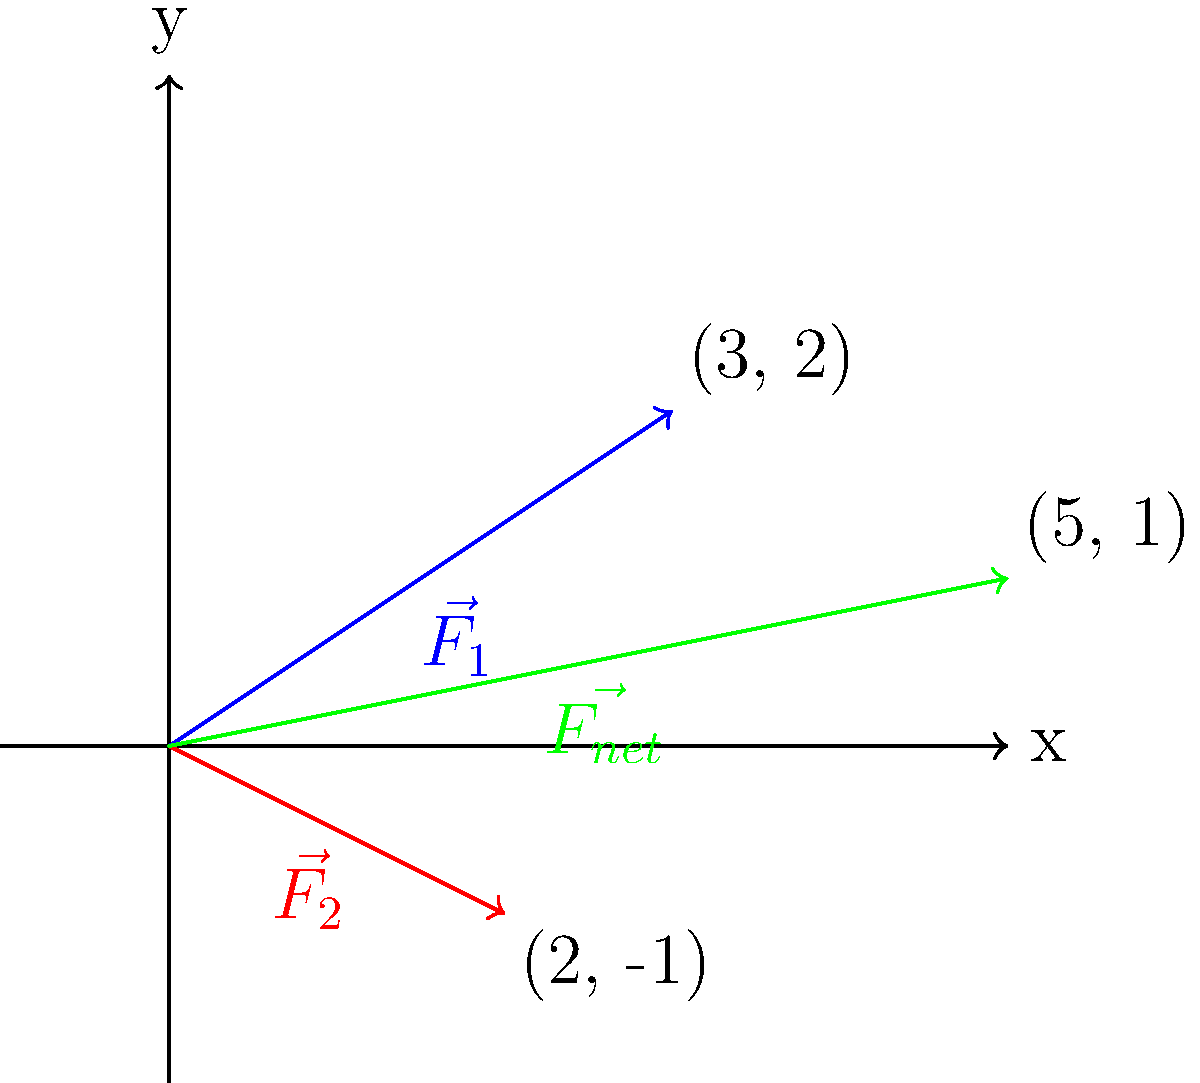In a championship match, you're about to execute your signature takedown technique. The technique involves applying two forces simultaneously: $\vec{F_1} = 3\hat{i} + 2\hat{j}$ and $\vec{F_2} = 2\hat{i} - \hat{j}$ (in arbitrary units). What is the magnitude of the net force $\vec{F_{net}}$ applied during this takedown? To find the magnitude of the net force, we need to follow these steps:

1. Determine the net force vector by adding the two force vectors:
   $\vec{F_{net}} = \vec{F_1} + \vec{F_2}$
   $\vec{F_{net}} = (3\hat{i} + 2\hat{j}) + (2\hat{i} - \hat{j})$
   $\vec{F_{net}} = 5\hat{i} + \hat{j}$

2. Calculate the magnitude of the net force using the Pythagorean theorem:
   $|\vec{F_{net}}| = \sqrt{(F_{net_x})^2 + (F_{net_y})^2}$
   $|\vec{F_{net}}| = \sqrt{5^2 + 1^2}$
   $|\vec{F_{net}}| = \sqrt{26}$

3. Simplify the result:
   $|\vec{F_{net}}| = \sqrt{26} \approx 5.10$ (rounded to two decimal places)

Therefore, the magnitude of the net force applied during the takedown is $\sqrt{26}$ units, or approximately 5.10 units.
Answer: $\sqrt{26}$ units 